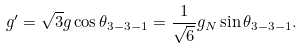Convert formula to latex. <formula><loc_0><loc_0><loc_500><loc_500>g ^ { \prime } = \sqrt { 3 } g \cos \theta _ { 3 - 3 - 1 } = \frac { 1 } { \sqrt { 6 } } g _ { N } \sin \theta _ { 3 - 3 - 1 } .</formula> 